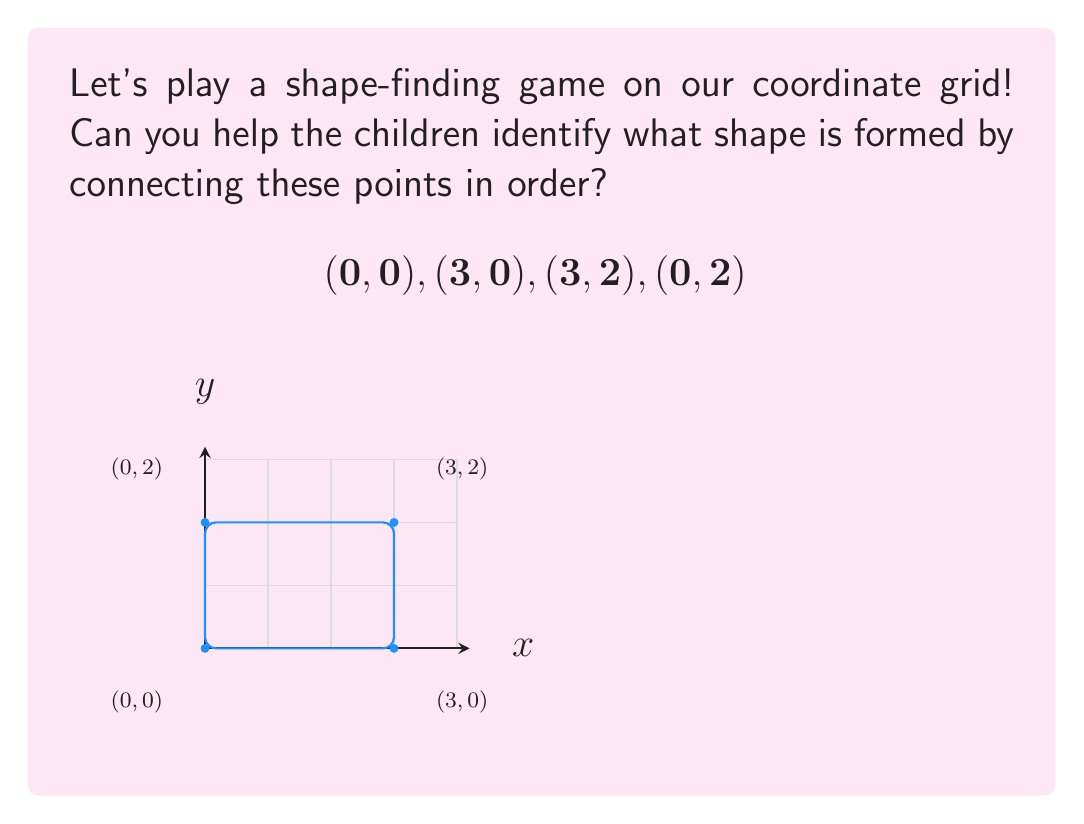Help me with this question. Let's break this down step-by-step to help our kindergarteners understand:

1) First, we plot the points on our coordinate grid:
   - $(0,0)$ is at the origin (where the x and y axes meet)
   - $(3,0)$ is 3 steps right from the origin
   - $(3,2)$ is 3 steps right and 2 steps up from the origin
   - $(0,2)$ is 2 steps up from the origin

2) Now, let's connect these points in order:
   - From $(0,0)$ to $(3,0)$: we draw a straight line to the right
   - From $(3,0)$ to $(3,2)$: we draw a straight line up
   - From $(3,2)$ to $(0,2)$: we draw a straight line to the left
   - From $(0,2)$ back to $(0,0)$: we draw a straight line down

3) Looking at the shape we've created:
   - It has four sides
   - All the corners are right angles (90 degrees)
   - The opposite sides are parallel and equal in length

4) These are all properties of a rectangle!

5) We can also observe that:
   - The width is 3 units (from x=0 to x=3)
   - The height is 2 units (from y=0 to y=2)

So, we've drawn a rectangle that is 3 units wide and 2 units tall.
Answer: Rectangle 